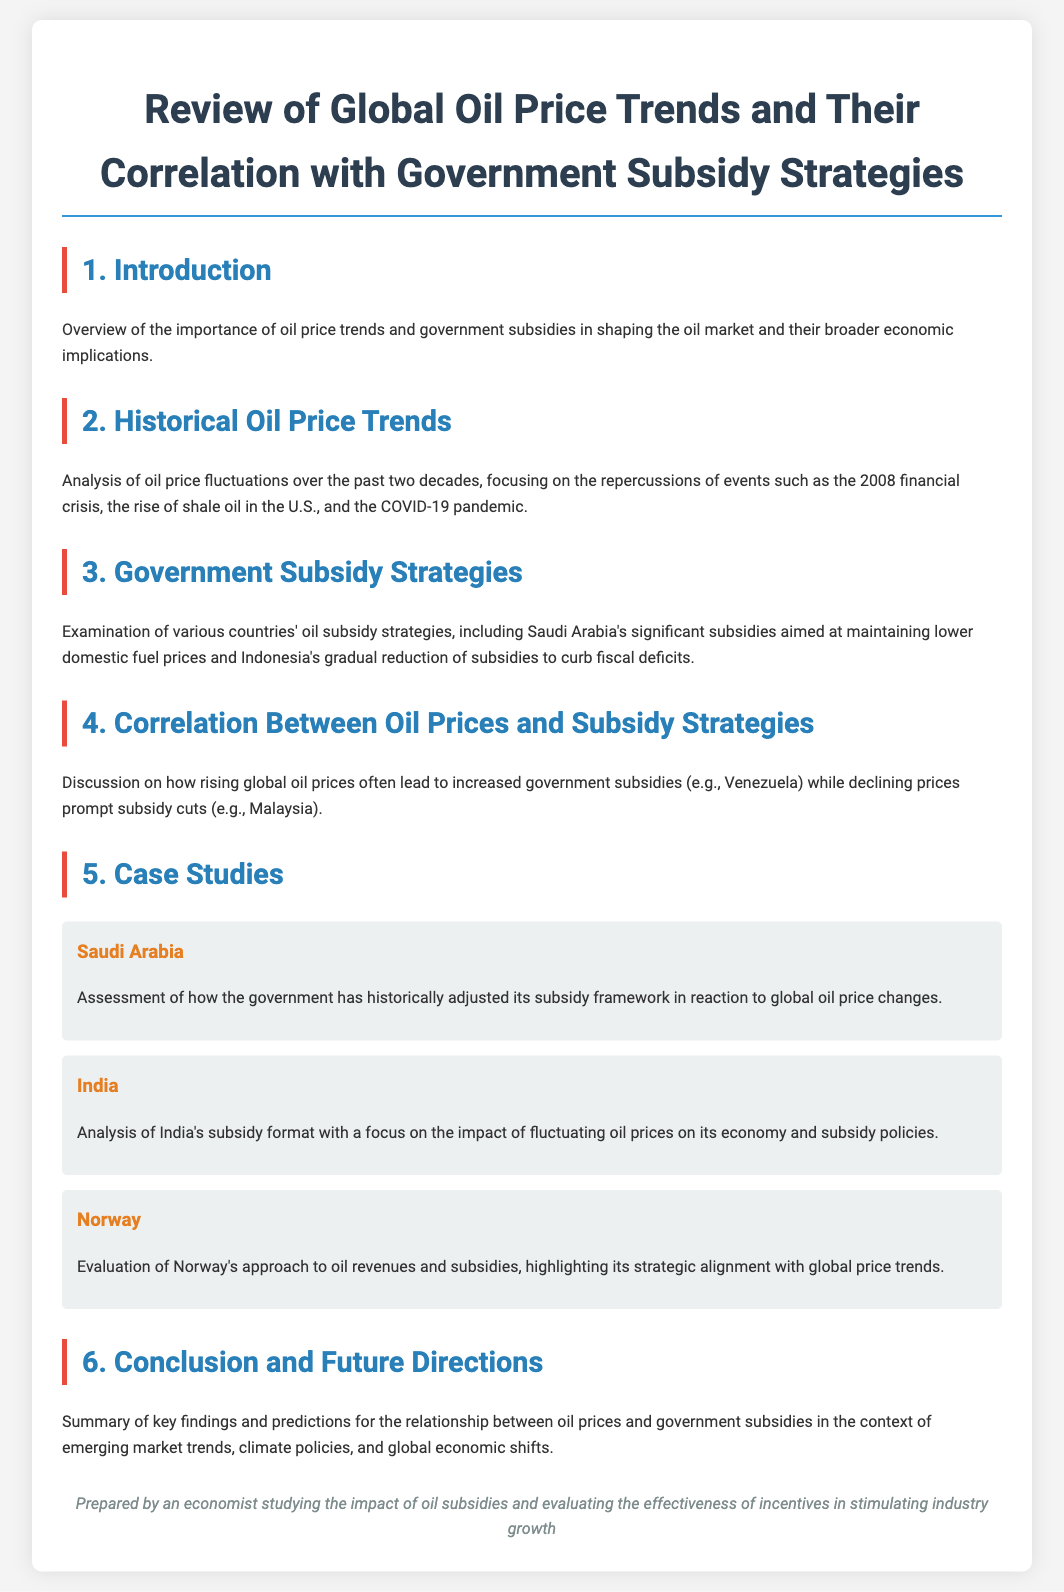What is the title of the document? The title of the document is found at the top of the rendered content, summarizing its focus on oil prices and subsidies.
Answer: Review of Global Oil Price Trends and Their Correlation with Government Subsidy Strategies What are the historical events analyzed in relation to oil price fluctuations? The document mentions specific key events impacting oil prices, which include the 2008 financial crisis, the rise of shale oil in the U.S., and the COVID-19 pandemic.
Answer: 2008 financial crisis, rise of shale oil, COVID-19 pandemic Which country’s subsidies are aimed at maintaining lower domestic fuel prices? The document specifically refers to Saudi Arabia's strategy of maintaining lower fuel prices through subsidies.
Answer: Saudi Arabia What is the focus of the case study on India? The case study on India centers on the impact of fluctuating oil prices on its economy and subsidy policies.
Answer: Impact of fluctuating oil prices How do rising global oil prices typically influence government subsidies? The document states that rising global oil prices often lead to increased government subsidies in certain countries.
Answer: Increased government subsidies What is the conclusion about future trends mentioned in the document? The conclusion includes key findings and predictions regarding the relationship between oil prices and government subsidies amidst various changing factors.
Answer: Emerging market trends, climate policies, global economic shifts 